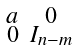<formula> <loc_0><loc_0><loc_500><loc_500>\begin{smallmatrix} a & 0 \\ 0 & I _ { n - m } \end{smallmatrix}</formula> 